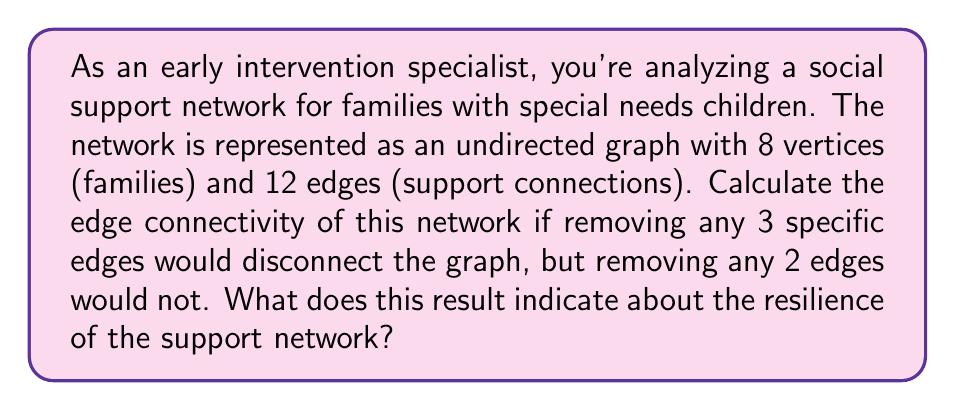What is the answer to this math problem? To solve this problem, we need to understand the concept of edge connectivity in graph theory and its application to social networks.

1. Edge connectivity definition:
   The edge connectivity of a graph, denoted as $\lambda(G)$, is the minimum number of edges that need to be removed to disconnect the graph.

2. Given information:
   - The graph has 8 vertices (families) and 12 edges (support connections)
   - Removing 3 specific edges disconnects the graph
   - Removing any 2 edges does not disconnect the graph

3. Determining edge connectivity:
   Since removing 3 specific edges disconnects the graph, but removing any 2 edges does not, we can conclude that the edge connectivity of this graph is 3.

   $$\lambda(G) = 3$$

4. Interpretation in the context of social support networks:
   The edge connectivity represents the minimum number of support connections that need to be removed to isolate a part of the network. A higher edge connectivity indicates a more resilient network.

   In this case, $\lambda(G) = 3$ means that at least 3 support connections need to be removed to isolate any family or group of families from the rest of the network. This indicates a moderate level of resilience in the support network.

5. Resilience assessment:
   - Low resilience: $\lambda(G) = 1$ or $2$
   - Moderate resilience: $\lambda(G) = 3$ or $4$
   - High resilience: $\lambda(G) \geq 5$

   The given network falls into the moderate resilience category, suggesting that while it has some strength, there is room for improvement in creating additional support connections to enhance the network's robustness.
Answer: The edge connectivity of the social support network is 3 ($\lambda(G) = 3$). This indicates a moderate level of resilience in the support network, suggesting that while the network has some strength, there is potential for improvement by creating additional support connections to enhance its robustness. 